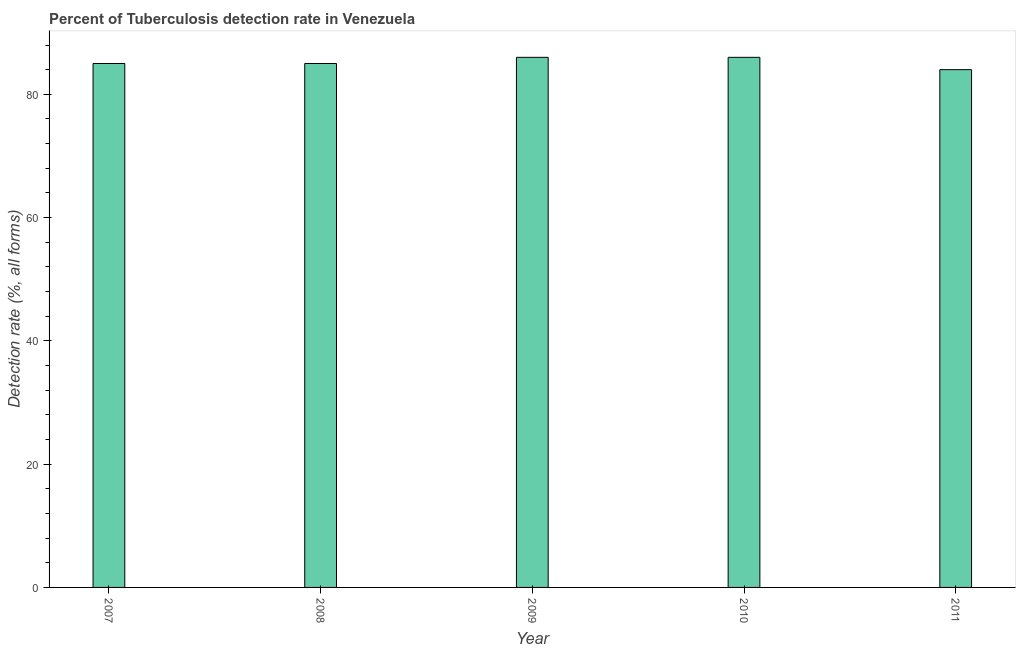Does the graph contain grids?
Ensure brevity in your answer.  No. What is the title of the graph?
Give a very brief answer. Percent of Tuberculosis detection rate in Venezuela. What is the label or title of the Y-axis?
Give a very brief answer. Detection rate (%, all forms). What is the detection rate of tuberculosis in 2007?
Provide a short and direct response. 85. In which year was the detection rate of tuberculosis maximum?
Your answer should be compact. 2009. In which year was the detection rate of tuberculosis minimum?
Your answer should be very brief. 2011. What is the sum of the detection rate of tuberculosis?
Provide a short and direct response. 426. What is the average detection rate of tuberculosis per year?
Your answer should be very brief. 85. What is the median detection rate of tuberculosis?
Your response must be concise. 85. In how many years, is the detection rate of tuberculosis greater than 24 %?
Your answer should be very brief. 5. Do a majority of the years between 2009 and 2011 (inclusive) have detection rate of tuberculosis greater than 8 %?
Ensure brevity in your answer.  Yes. What is the difference between the highest and the lowest detection rate of tuberculosis?
Your answer should be compact. 2. In how many years, is the detection rate of tuberculosis greater than the average detection rate of tuberculosis taken over all years?
Keep it short and to the point. 2. How many bars are there?
Offer a terse response. 5. Are all the bars in the graph horizontal?
Provide a succinct answer. No. How many years are there in the graph?
Your answer should be very brief. 5. Are the values on the major ticks of Y-axis written in scientific E-notation?
Provide a succinct answer. No. What is the Detection rate (%, all forms) of 2007?
Keep it short and to the point. 85. What is the Detection rate (%, all forms) of 2008?
Keep it short and to the point. 85. What is the Detection rate (%, all forms) in 2009?
Make the answer very short. 86. What is the difference between the Detection rate (%, all forms) in 2007 and 2008?
Your answer should be compact. 0. What is the difference between the Detection rate (%, all forms) in 2007 and 2010?
Make the answer very short. -1. What is the difference between the Detection rate (%, all forms) in 2007 and 2011?
Provide a short and direct response. 1. What is the difference between the Detection rate (%, all forms) in 2008 and 2009?
Give a very brief answer. -1. What is the difference between the Detection rate (%, all forms) in 2008 and 2010?
Offer a terse response. -1. What is the difference between the Detection rate (%, all forms) in 2009 and 2010?
Your answer should be compact. 0. What is the ratio of the Detection rate (%, all forms) in 2007 to that in 2009?
Keep it short and to the point. 0.99. What is the ratio of the Detection rate (%, all forms) in 2008 to that in 2009?
Offer a terse response. 0.99. What is the ratio of the Detection rate (%, all forms) in 2009 to that in 2011?
Offer a very short reply. 1.02. What is the ratio of the Detection rate (%, all forms) in 2010 to that in 2011?
Provide a short and direct response. 1.02. 